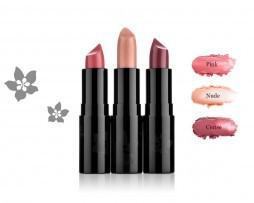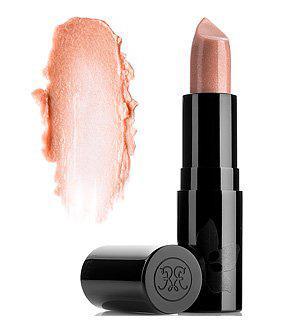The first image is the image on the left, the second image is the image on the right. Assess this claim about the two images: "The image on the right has a lipstick smudge on the left side of a single tube of lipstick.". Correct or not? Answer yes or no. Yes. The first image is the image on the left, the second image is the image on the right. For the images shown, is this caption "An image shows one upright tube lipstick next to its horizontal cap and a smear of color." true? Answer yes or no. Yes. 